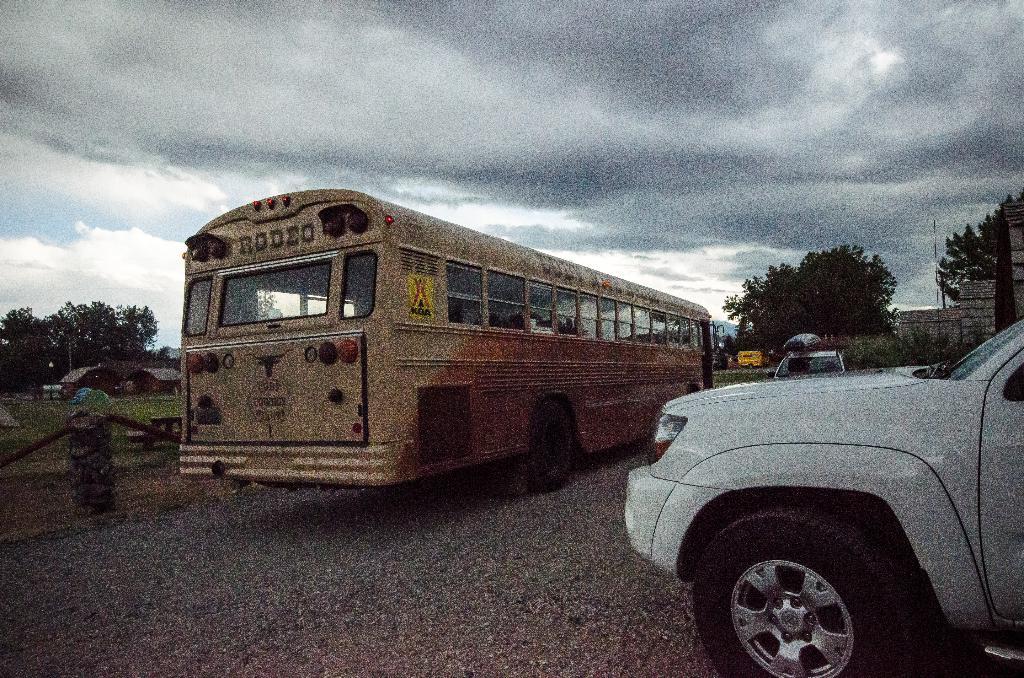Where is the bus going?
Ensure brevity in your answer.  Rodeo. 